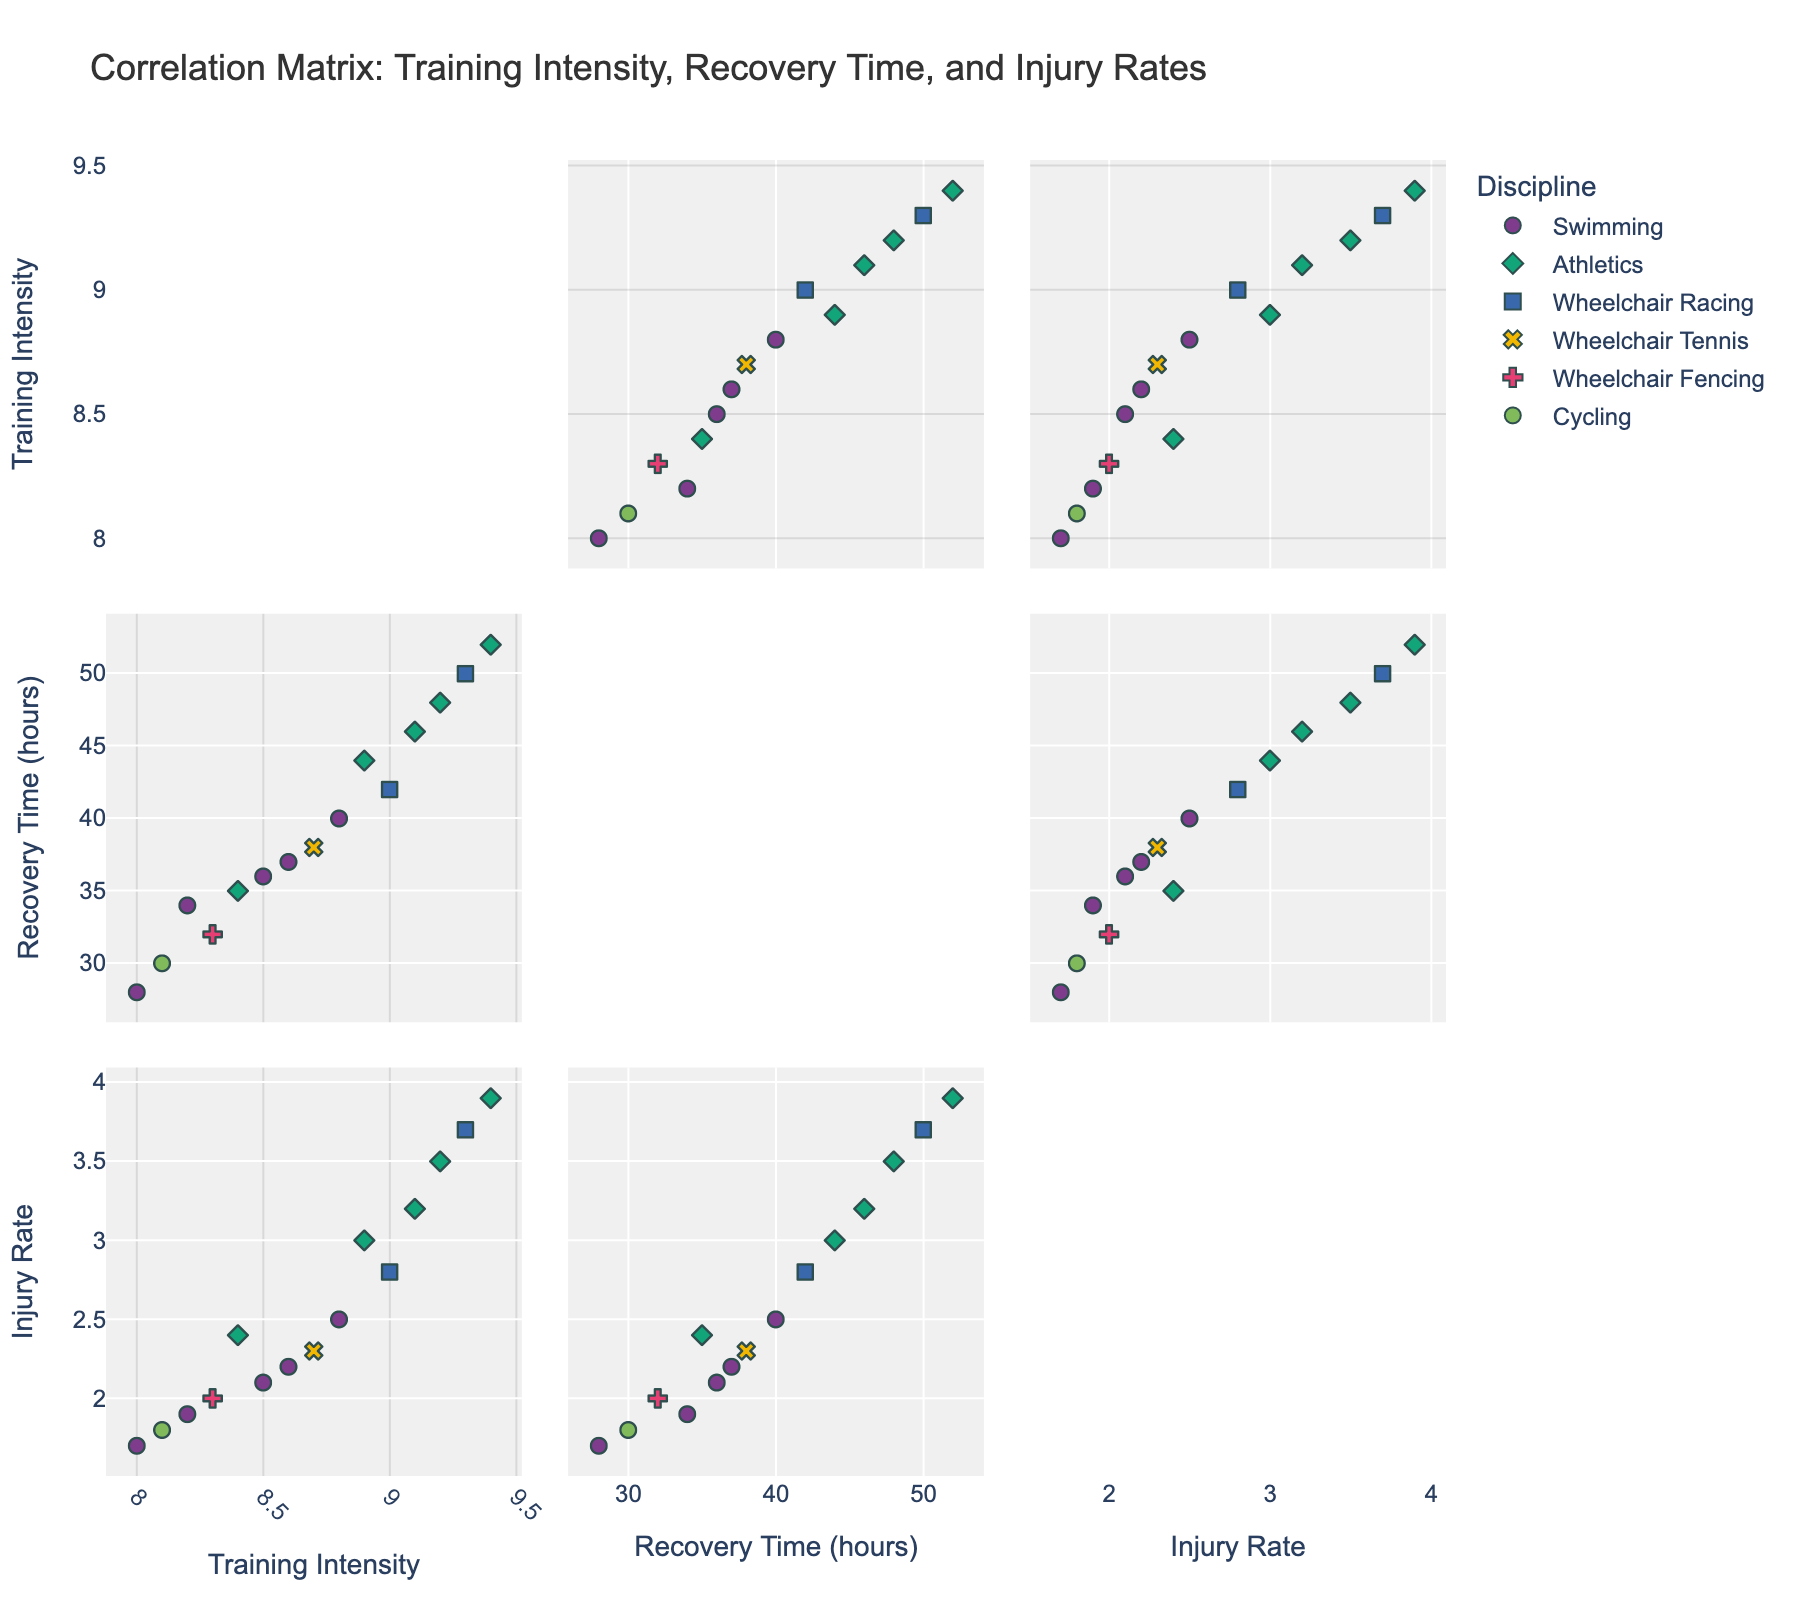What is the title of the plot? By reading the top of the figure, you can find the title easily which describes the main subject of the scatterplot matrix.
Answer: Correlation Matrix: Training Intensity, Recovery Time, and Injury Rates What are the axes labeled with? By examining the figure, look at the axis labels that describe what each scatterplot in the matrix represents. The x-axes and y-axes are labeled as follows: 'Training Intensity', 'Recovery Time (hours)', and 'Injury Rate'.
Answer: Training Intensity, Recovery Time (hours), Injury Rate How many disciplines are represented in the scatterplot matrix? By observing the different colors and symbols in the figure, you can count the number of unique disciplines noted in the legend.
Answer: 6 Which athlete has the highest training intensity? Find the data point with the highest value on the Training Intensity axis and hover over it to see the athlete's name.
Answer: Markus Rehm Is there any clear correlation between Training Intensity and Injury Rate? Examining the scatter plots that compare Training Intensity to Injury Rate, look to see if there's an obvious trend, like an upward or downward slope.
Answer: No clear correlation Which discipline generally has the highest recovery time? Compare the recovery times within each discipline by looking at the Recovery Time (hours) axis, noting which discipline's points trend higher.
Answer: Athletics What is the relationship between Recovery Time and Injury Rate? Look at the scatterplot for Recovery Time vs. Injury Rate and determine if longer recovery times are associated with higher or lower injury rates.
Answer: Slight positive correlation Who are the athletes with the lowest injury rate? Look at the scatter plots involving the Injury Rate axis, specifically near the lowest values, and identify the athletes.
Answer: Ellie Cole, Jody Cundy Which discipline shows a varied range in training intensity? Observe the distribution of training intensity values within each discipline and identify the one that spans a wider range.
Answer: Athletics How does Marcel Hug's Injury Rate compare to Becca Meyers'? Find Marcel Hug and Becca Meyers' data points and compare their positions on the Injury Rate axis to see whose injury rate is higher.
Answer: Marcel Hug has a higher Injury Rate 